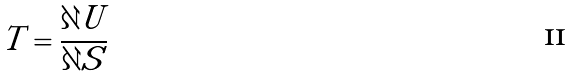<formula> <loc_0><loc_0><loc_500><loc_500>T = \frac { \partial U } { \partial S }</formula> 